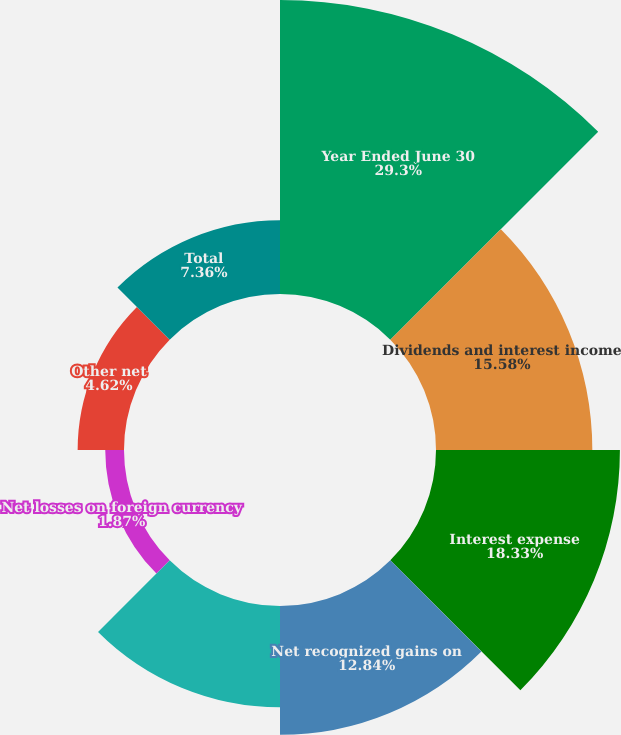Convert chart. <chart><loc_0><loc_0><loc_500><loc_500><pie_chart><fcel>Year Ended June 30<fcel>Dividends and interest income<fcel>Interest expense<fcel>Net recognized gains on<fcel>Net losses on derivatives<fcel>Net losses on foreign currency<fcel>Other net<fcel>Total<nl><fcel>29.3%<fcel>15.58%<fcel>18.33%<fcel>12.84%<fcel>10.1%<fcel>1.87%<fcel>4.62%<fcel>7.36%<nl></chart> 